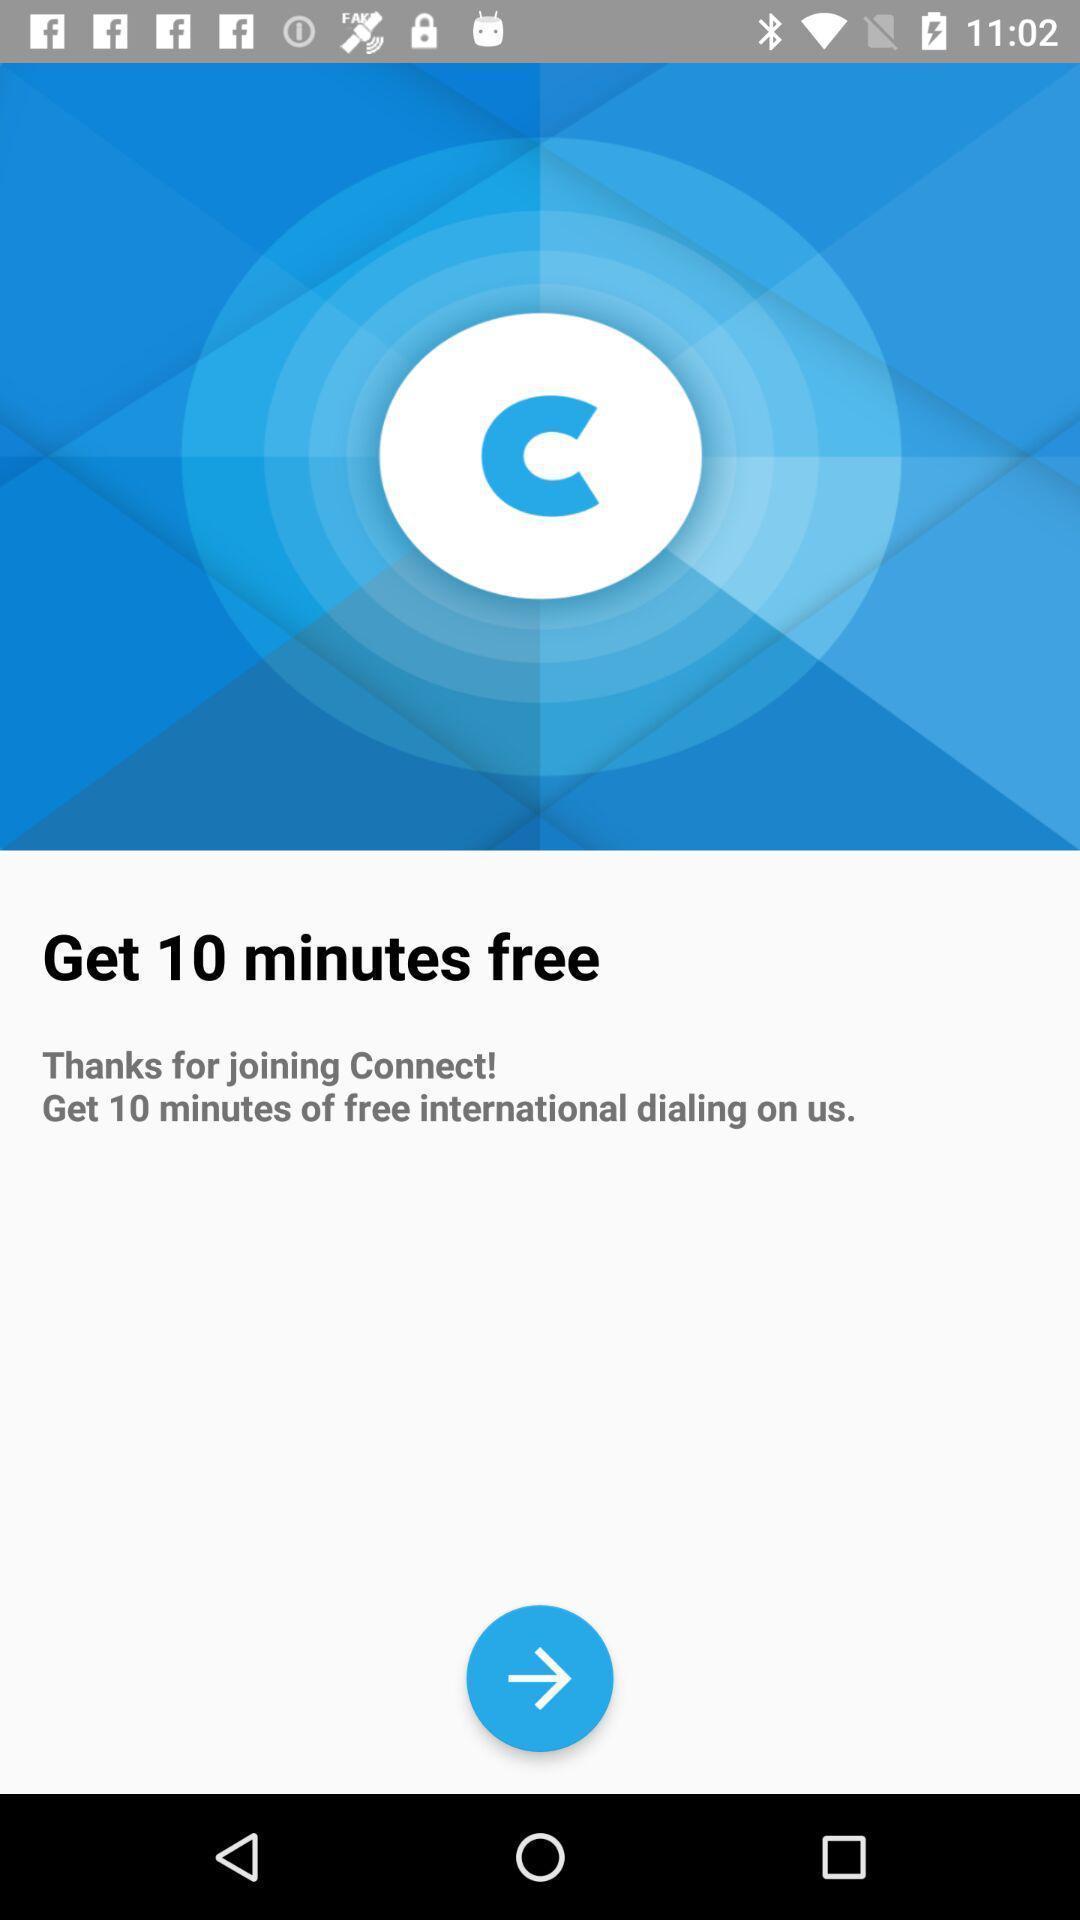Provide a textual representation of this image. Window displaying an calling app. 